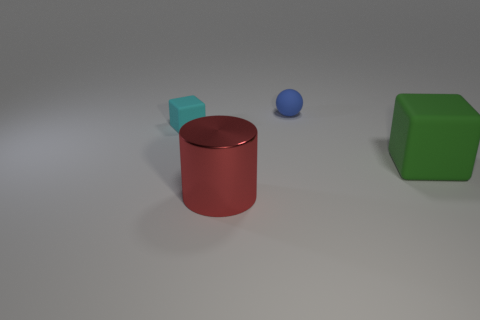Is the number of rubber objects that are left of the small rubber sphere the same as the number of tiny cyan matte things to the right of the big block?
Offer a terse response. No. What material is the cube that is on the right side of the big red metallic cylinder in front of the green rubber object made of?
Offer a very short reply. Rubber. What number of objects are either cyan rubber objects or things that are on the right side of the cyan cube?
Provide a short and direct response. 4. What is the size of the blue thing that is the same material as the small cyan object?
Ensure brevity in your answer.  Small. Is the number of small objects behind the large cube greater than the number of gray shiny balls?
Provide a short and direct response. Yes. There is a rubber object that is in front of the sphere and left of the green thing; what is its size?
Provide a short and direct response. Small. There is a tiny cyan thing that is the same shape as the big green thing; what is it made of?
Offer a terse response. Rubber. Are there an equal number of big brown shiny objects and blue rubber spheres?
Offer a terse response. No. Does the matte object behind the cyan matte thing have the same size as the green thing?
Offer a very short reply. No. There is a thing that is to the left of the tiny blue matte thing and behind the red object; what is its color?
Give a very brief answer. Cyan. 